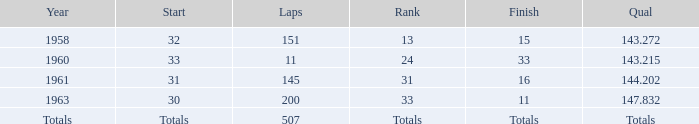What's the Finish rank of 31? 16.0. 